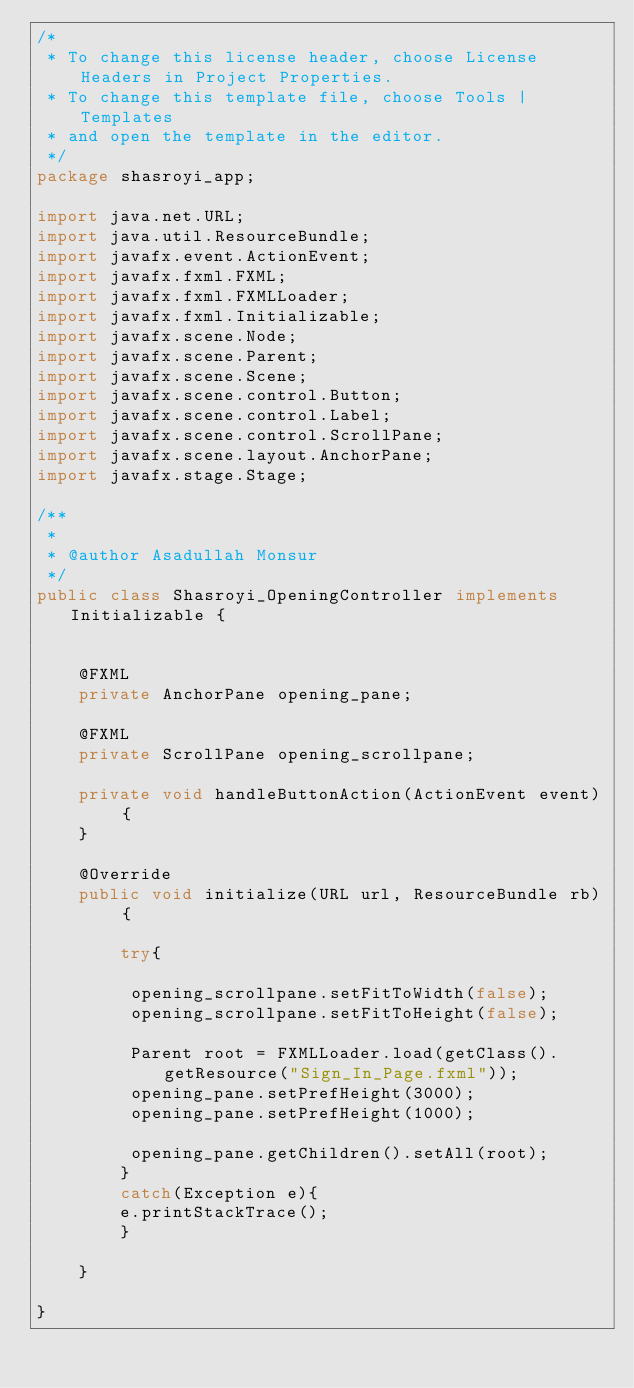Convert code to text. <code><loc_0><loc_0><loc_500><loc_500><_Java_>/*
 * To change this license header, choose License Headers in Project Properties.
 * To change this template file, choose Tools | Templates
 * and open the template in the editor.
 */
package shasroyi_app;

import java.net.URL;
import java.util.ResourceBundle;
import javafx.event.ActionEvent;
import javafx.fxml.FXML;
import javafx.fxml.FXMLLoader;
import javafx.fxml.Initializable;
import javafx.scene.Node;
import javafx.scene.Parent;
import javafx.scene.Scene;
import javafx.scene.control.Button;
import javafx.scene.control.Label;
import javafx.scene.control.ScrollPane;
import javafx.scene.layout.AnchorPane;
import javafx.stage.Stage;

/**
 *
 * @author Asadullah Monsur
 */
public class Shasroyi_OpeningController implements Initializable {
    
   
    @FXML
    private AnchorPane opening_pane;
    
    @FXML
    private ScrollPane opening_scrollpane;
    
    private void handleButtonAction(ActionEvent event) {
    }
    
    @Override
    public void initialize(URL url, ResourceBundle rb) {
        
        try{
        
         opening_scrollpane.setFitToWidth(false); 
         opening_scrollpane.setFitToHeight(false); 
            
         Parent root = FXMLLoader.load(getClass().getResource("Sign_In_Page.fxml"));
         opening_pane.setPrefHeight(3000);
         opening_pane.setPrefHeight(1000);
         
         opening_pane.getChildren().setAll(root);
        }
        catch(Exception e){
        e.printStackTrace();
        }
      
    }    
    
}
</code> 